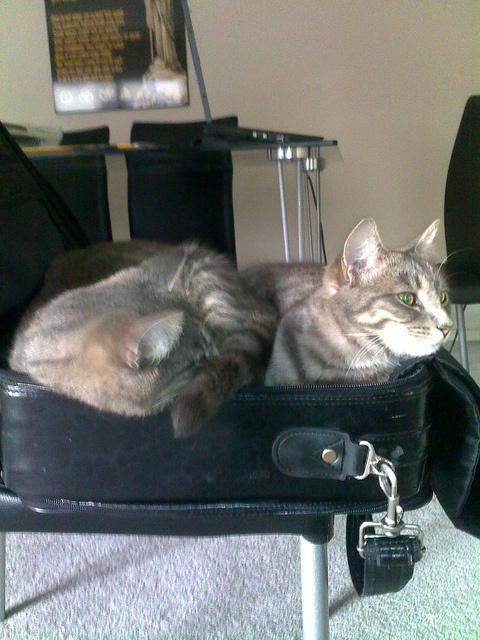Describe the objects in this image and their specific colors. I can see suitcase in tan, black, gray, and purple tones, cat in tan, gray, darkgray, black, and lightgray tones, chair in tan, black, gray, and blue tones, and chair in tan, black, gray, and darkgray tones in this image. 